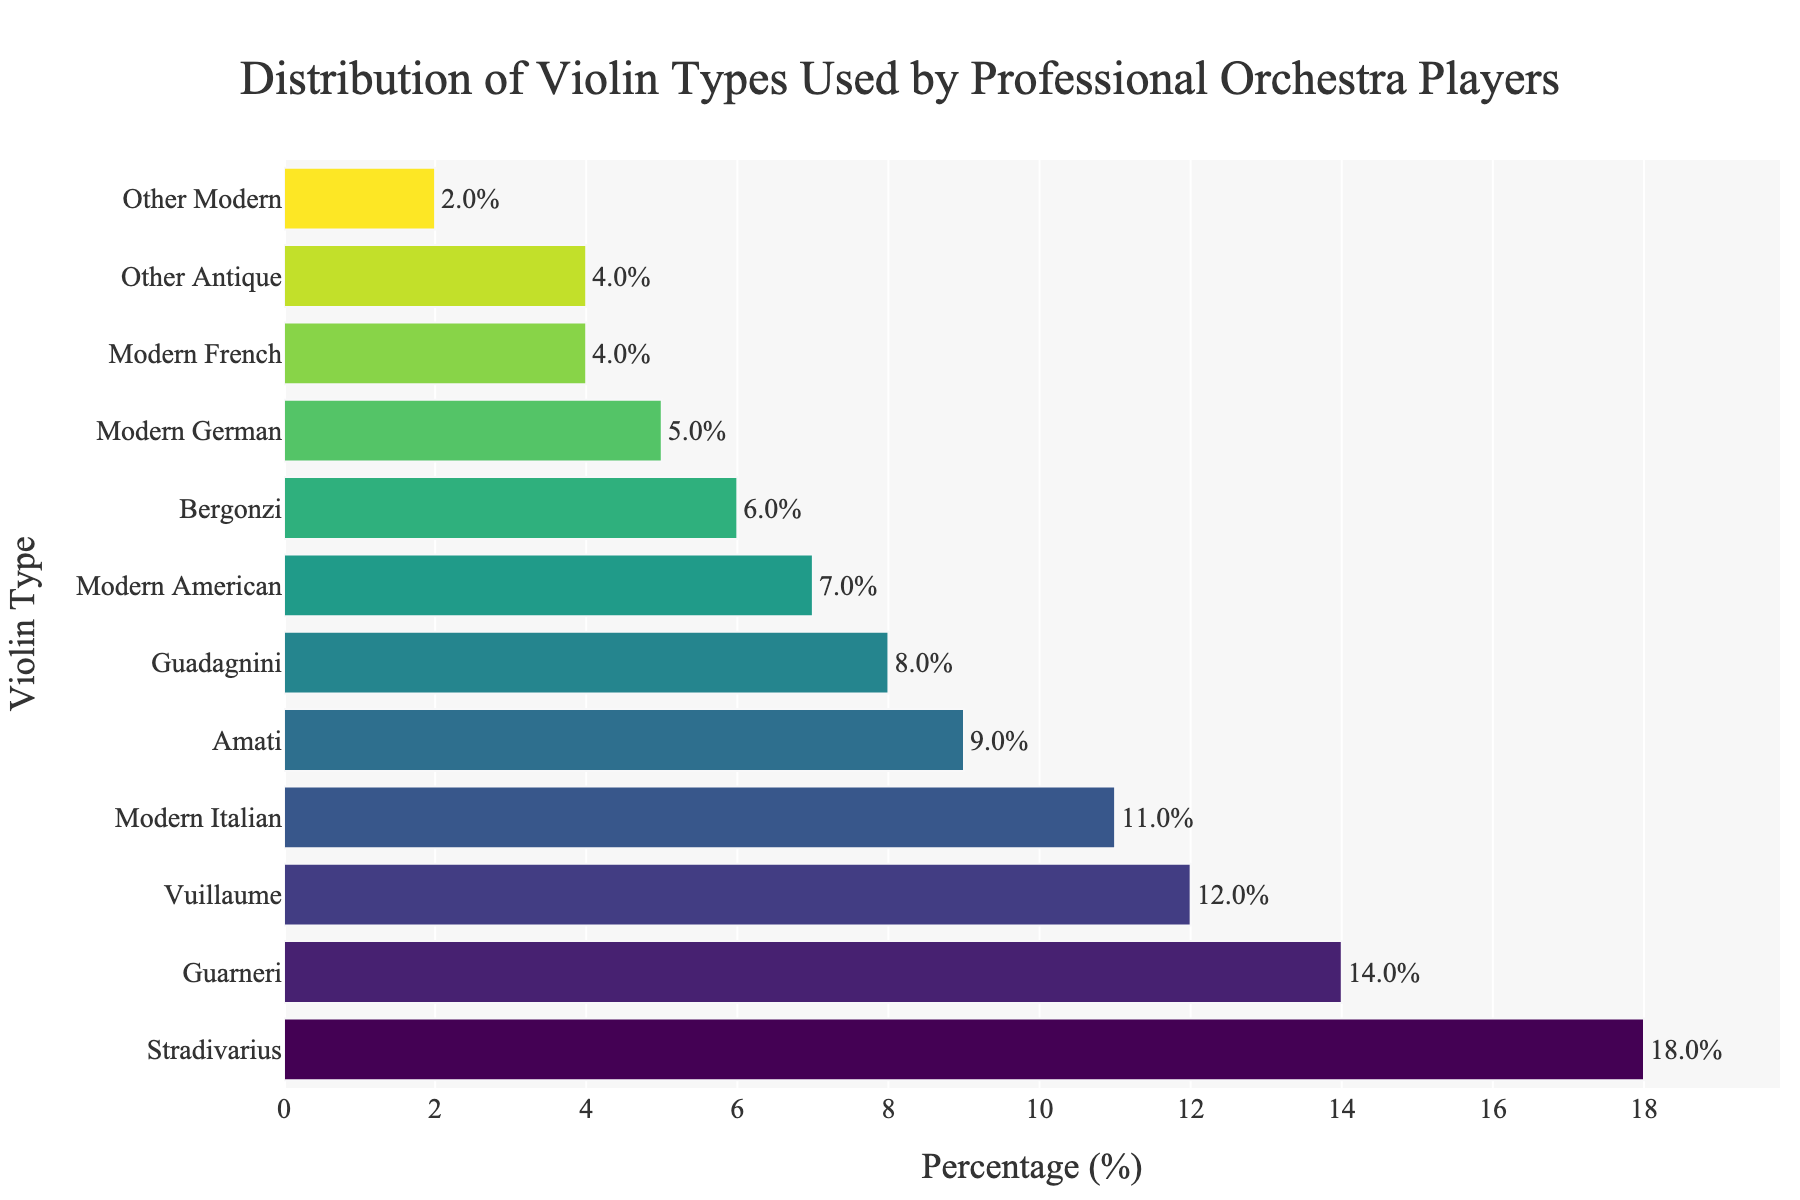What is the most commonly used violin type among professional orchestra players? The bar chart shows that the "Stradivarius" violin has the highest percentage among all listed types.
Answer: Stradivarius Which violin type is used less frequently, Guarneri or Amati? The chart shows that "Guarneri" has a higher percentage (14%) compared to "Amati" (9%).
Answer: Amati How much more popular is the Vuillaume violin compared to the Modern German violin? The percentage of Vuillaume is 12% and that of Modern German is 5%. The difference is 12% - 5% = 7%.
Answer: 7% What is the combined percentage of players using Bergonzi and Modern French violins? The percentage for Bergonzi is 6% and for Modern French is 4%. Their combined percentage is 6% + 4% = 10%.
Answer: 10% Which violin types have the same percentage of usage? The chart indicates that "Other Antique" and "Other Modern" both have a percentage of 4%.
Answer: Other Antique and Other Modern What is the least common category of violins used by professional orchestra players? The chart shows that "Other Modern" has the lowest percentage, which is 2%.
Answer: Other Modern How does the usage of Guadagnini violins compare with Modern Italian violins? The percentage for Guadagnini is 8% while Modern Italian is 11%. Guadagnini is less used compared to Modern Italian by 3%.
Answer: Modern Italian is more used By how much does the popularity of Stradivarius violins exceed the combined usage of Modern German and Modern French violins? The percentage for Stradivarius is 18%. The combined percentage for Modern German (5%) and Modern French (4%) is 5% + 4% = 9%. The excess is 18% - 9% = 9%.
Answer: 9% What visual indicator shows which violin type is the most popular? The longest bar in the chart corresponds to the "Stradivarius" violin, indicating it is the most popular.
Answer: The length of the bar Which violin types fall in the middle range of popularity, between 5% and 10%? The chart shows the violin types between 5% and 10% are Amati (9%), Guadagnini (8%), Bergonzi (6%), and Modern American (7%).
Answer: Amati, Guadagnini, Bergonzi, Modern American 